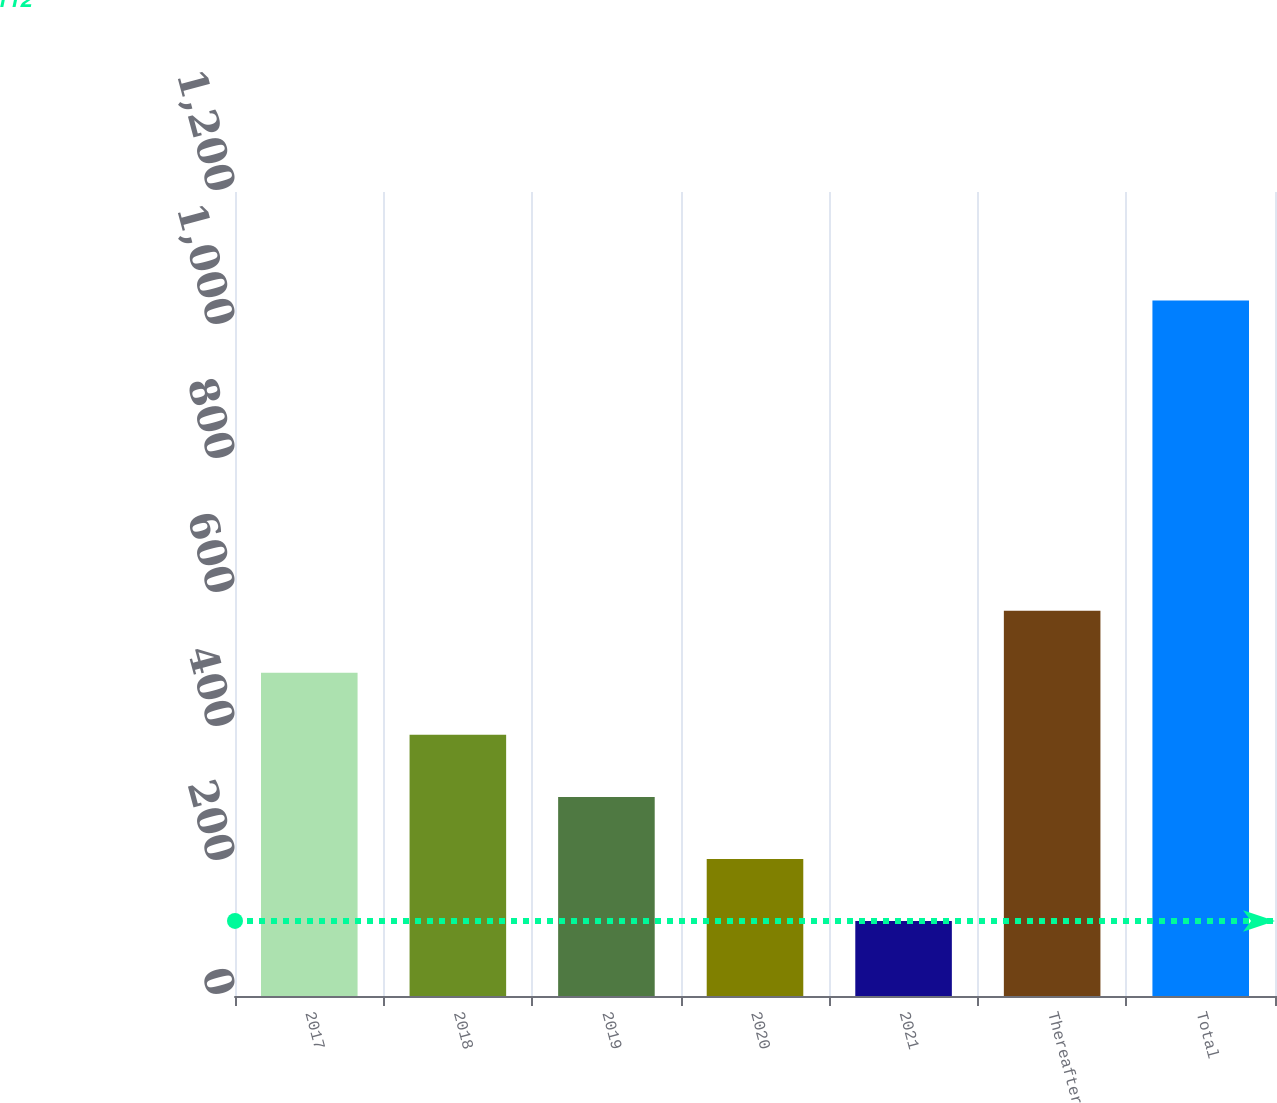Convert chart. <chart><loc_0><loc_0><loc_500><loc_500><bar_chart><fcel>2017<fcel>2018<fcel>2019<fcel>2020<fcel>2021<fcel>Thereafter<fcel>Total<nl><fcel>482.4<fcel>389.8<fcel>297.2<fcel>204.6<fcel>112<fcel>575<fcel>1038<nl></chart> 